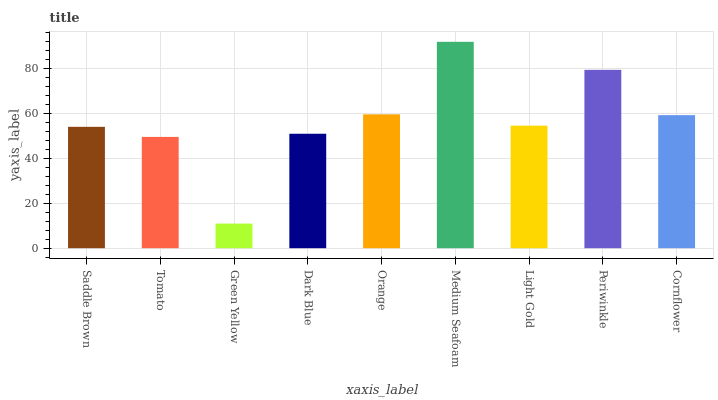Is Green Yellow the minimum?
Answer yes or no. Yes. Is Medium Seafoam the maximum?
Answer yes or no. Yes. Is Tomato the minimum?
Answer yes or no. No. Is Tomato the maximum?
Answer yes or no. No. Is Saddle Brown greater than Tomato?
Answer yes or no. Yes. Is Tomato less than Saddle Brown?
Answer yes or no. Yes. Is Tomato greater than Saddle Brown?
Answer yes or no. No. Is Saddle Brown less than Tomato?
Answer yes or no. No. Is Light Gold the high median?
Answer yes or no. Yes. Is Light Gold the low median?
Answer yes or no. Yes. Is Periwinkle the high median?
Answer yes or no. No. Is Cornflower the low median?
Answer yes or no. No. 